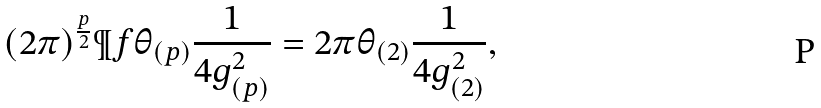Convert formula to latex. <formula><loc_0><loc_0><loc_500><loc_500>( 2 \pi ) ^ { \frac { p } { 2 } } \P f \theta _ { ( p ) } \frac { 1 } { 4 g _ { ( p ) } ^ { 2 } } = 2 \pi \theta _ { ( 2 ) } \frac { 1 } { 4 g _ { ( 2 ) } ^ { 2 } } ,</formula> 